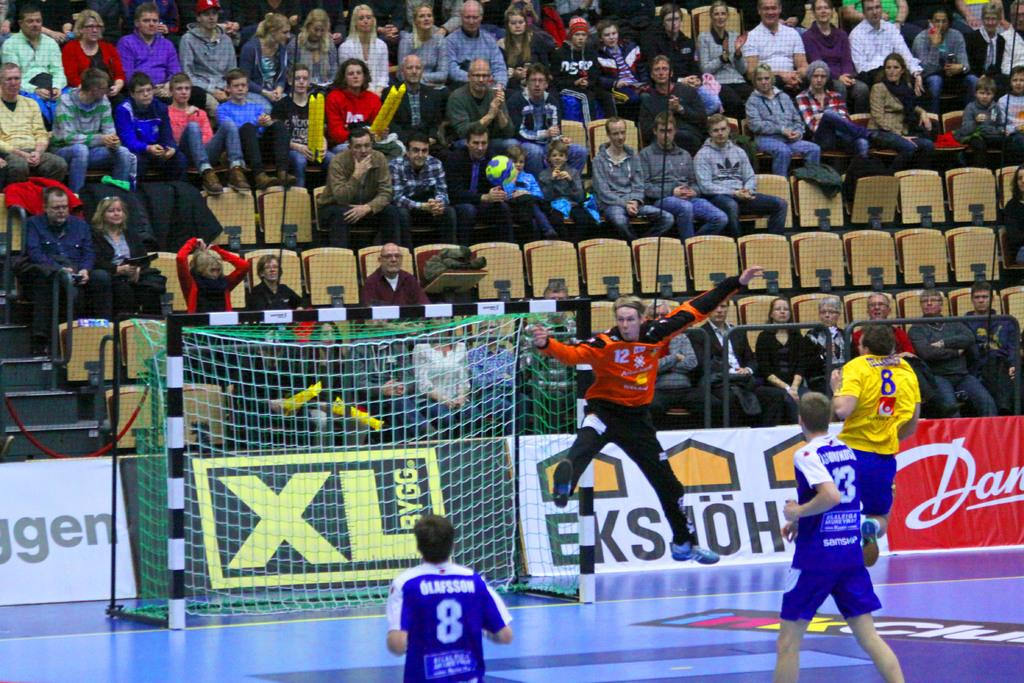<image>
Share a concise interpretation of the image provided. A soccer game is underway and a player's uniform says Olafsson. 